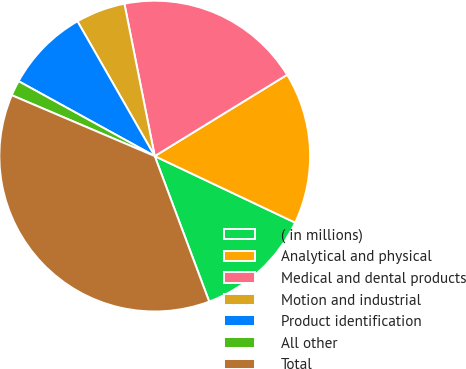Convert chart to OTSL. <chart><loc_0><loc_0><loc_500><loc_500><pie_chart><fcel>( in millions)<fcel>Analytical and physical<fcel>Medical and dental products<fcel>Motion and industrial<fcel>Product identification<fcel>All other<fcel>Total<nl><fcel>12.26%<fcel>15.81%<fcel>19.36%<fcel>5.16%<fcel>8.71%<fcel>1.6%<fcel>37.11%<nl></chart> 